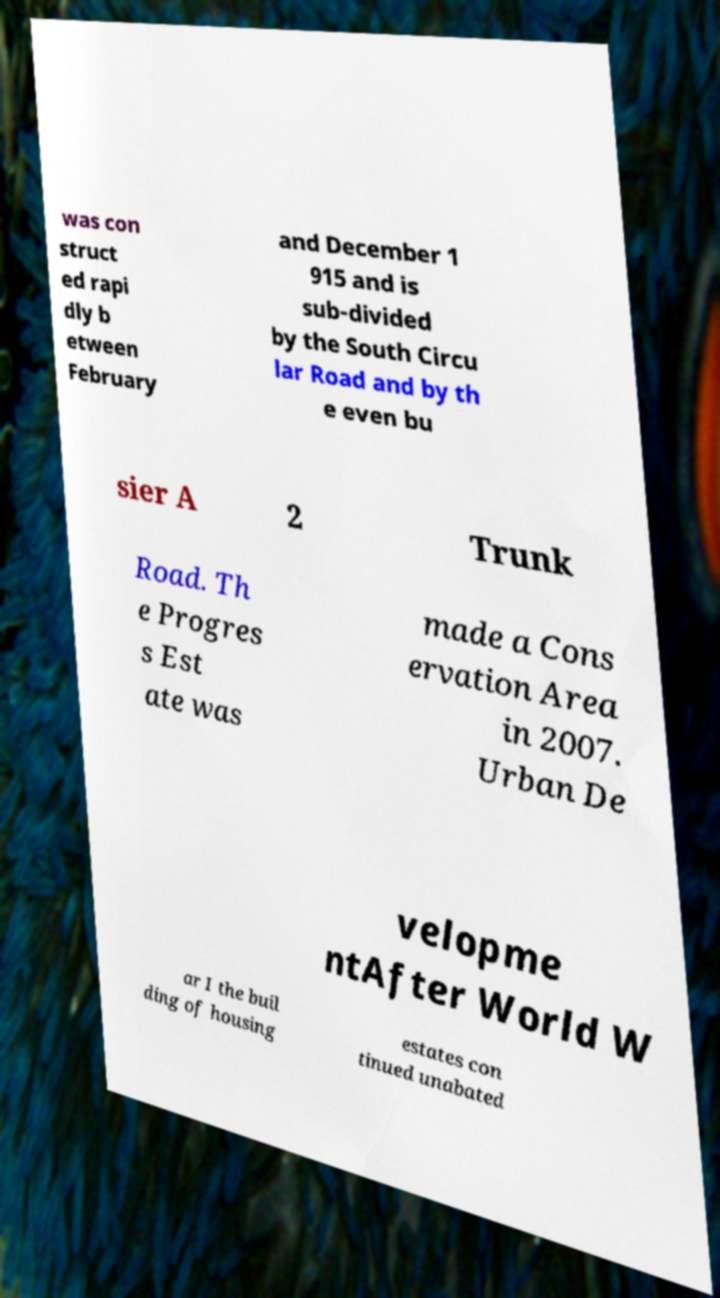Can you read and provide the text displayed in the image?This photo seems to have some interesting text. Can you extract and type it out for me? was con struct ed rapi dly b etween February and December 1 915 and is sub-divided by the South Circu lar Road and by th e even bu sier A 2 Trunk Road. Th e Progres s Est ate was made a Cons ervation Area in 2007. Urban De velopme ntAfter World W ar I the buil ding of housing estates con tinued unabated 